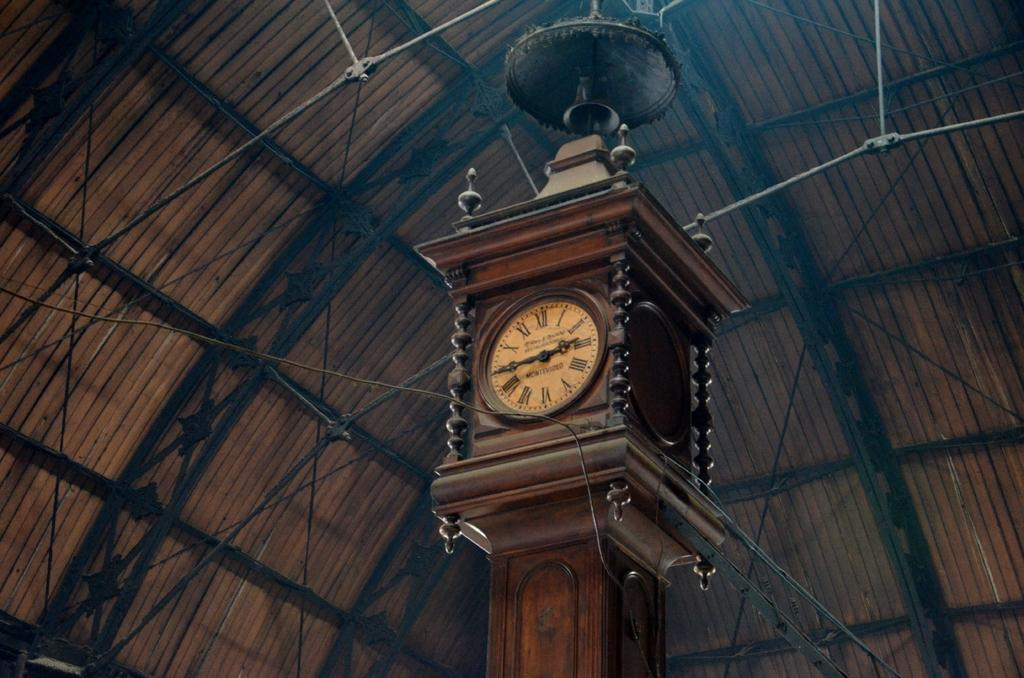Provide a one-sentence caption for the provided image. An ornate clock has the word Montevideo within the circle of its Roman numerals. 